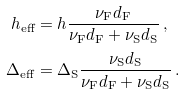Convert formula to latex. <formula><loc_0><loc_0><loc_500><loc_500>h _ { \text {eff} } & = h \frac { \nu _ { \text {F} } d _ { \text {F} } } { \nu _ { \text {F} } d _ { \text {F} } + \nu _ { \text {S} } d _ { \text {S} } } \, , \\ \Delta _ { \text {eff} } & = \Delta _ { \text {S} } \frac { \nu _ { \text {S} } d _ { \text {S} } } { \nu _ { \text {F} } d _ { \text {F} } + \nu _ { \text {S} } d _ { \text {S} } } \, .</formula> 